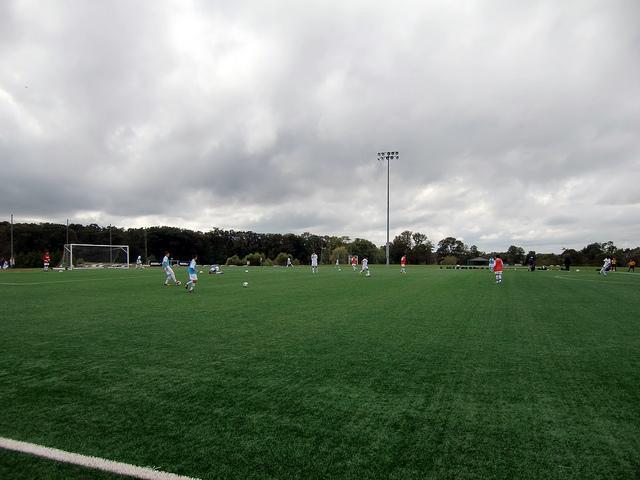How many batters do you see?
Give a very brief answer. 0. How many skis are level against the snow?
Give a very brief answer. 0. 